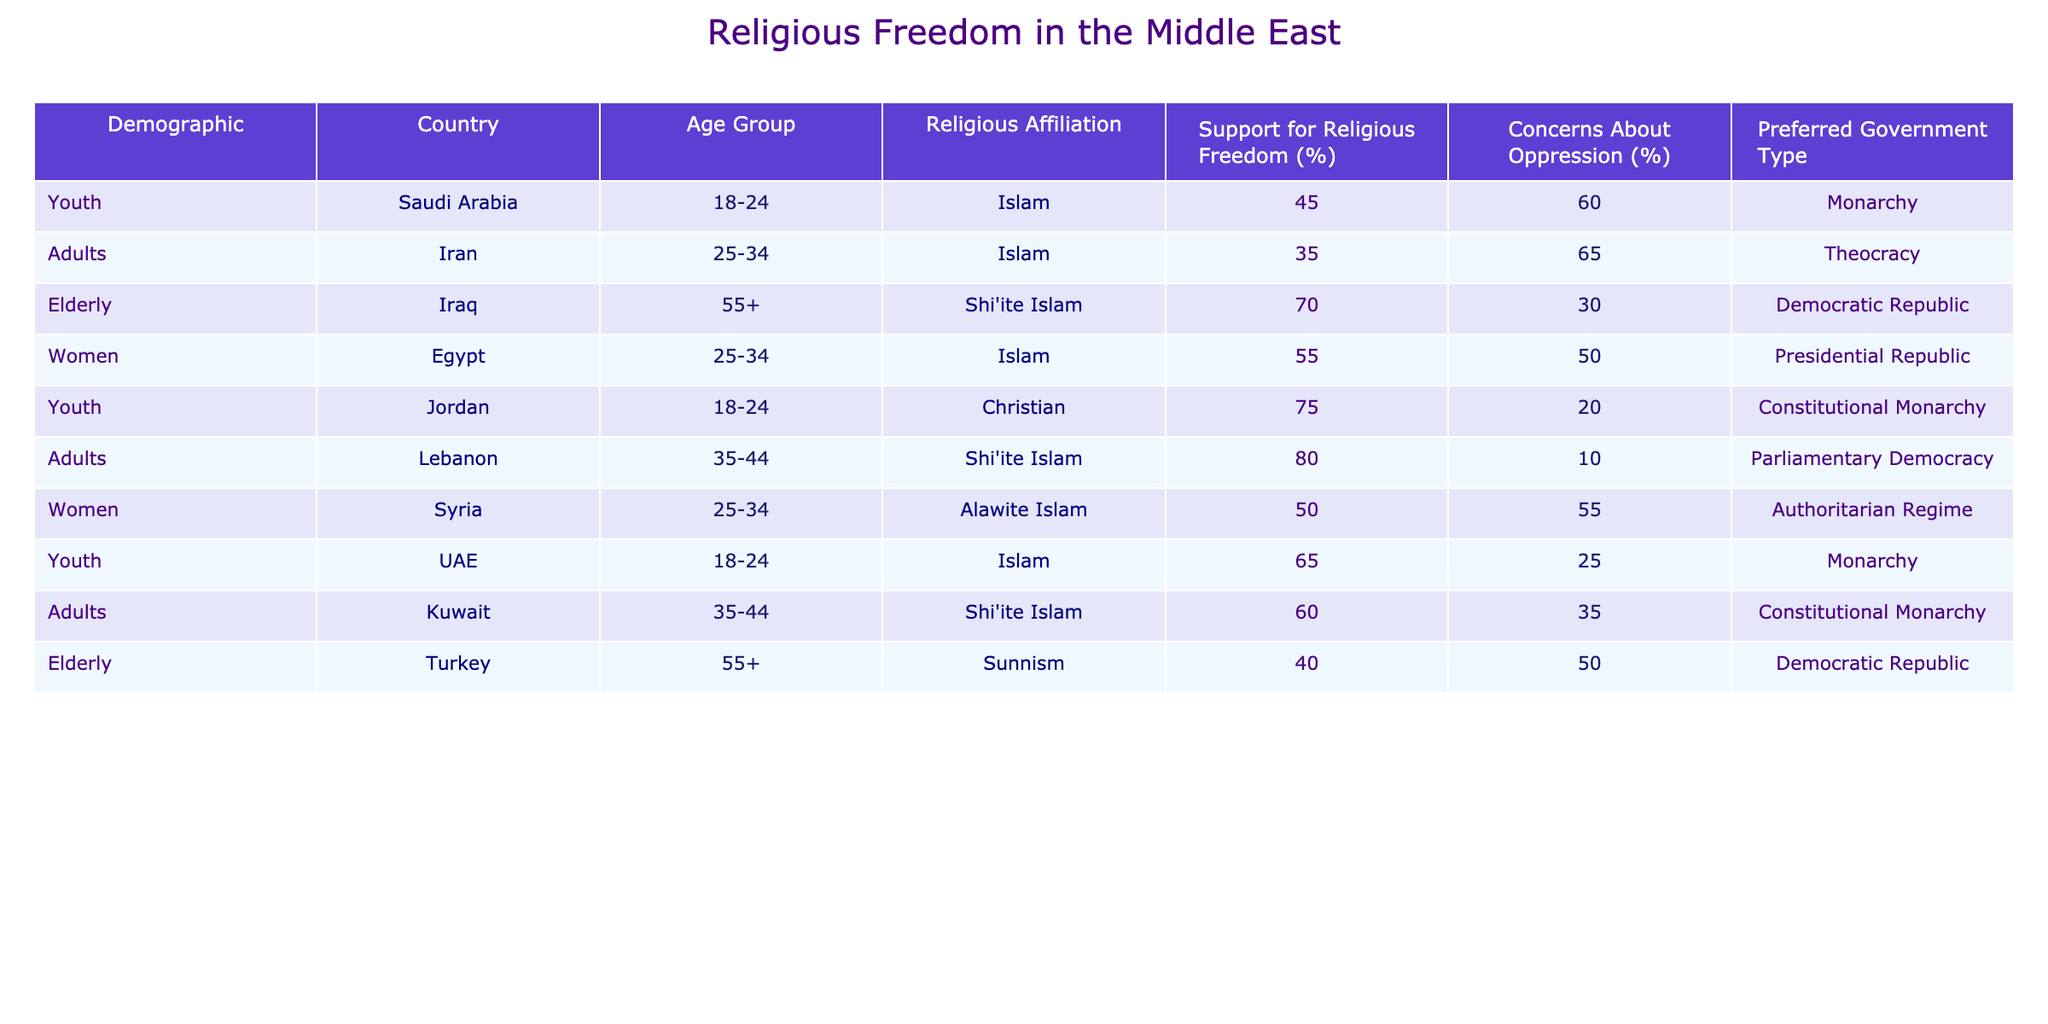What percentage of youth in Saudi Arabia support religious freedom? From the table, under the Saudi Arabia entry and the youth demographic (18-24 age group), the support for religious freedom is listed as 45%.
Answer: 45% Which country has the highest percentage of support for religious freedom among Shi'ite Muslims? Looking at the table, Lebanon has the highest support for religious freedom at 80%, under the adults demographic (35-44 age group).
Answer: Lebanon, 80% Is there a group in Iraq that has more concerns about oppression than support for religious freedom? In the table, the elderly demographic (55+) identified as Shi'ite Islam in Iraq shows support for religious freedom at 70% and concerns about oppression at 30%, which means support is higher than concerns. Therefore, the answer is no.
Answer: No What is the average support for religious freedom among women across the different countries listed? From the table, the support for religious freedom among women are: Egypt (55%), Syria (50%). Adding these gives 105%, and dividing by 2 leads to an average of 52.5%.
Answer: 52.5% Which age group in Jordan has the highest support for religious freedom? The table lists one demographic for Jordan (youth, 18-24) which shows a support level of 75%. Since this is the only data point provided for Jordan, it is confirmed that the youth group is the highest support.
Answer: Youth, 75% How do concerns about oppression compare between the youth in UAE and adults in Kuwait? The table shows that youth in UAE have concerns about oppression at 25% while adults in Kuwait have concerns at 35%. Therefore, adults in Kuwait have higher concerns about oppression by a difference of 10%.
Answer: Adults in Kuwait, 10% higher Is support for religious freedom generally higher among the elderly compared to youth across the table? The table shows the following averages: youth support (Saudi Arabia 45%, Jordan 75%, UAE 65% gives 61.67%) and elderly support (Iraq 70%, Turkey 40% gives 55%). The elderly group averages lower support than the youth group, concluding that youth have generally higher support.
Answer: No What percentage of Shi'ite Muslims in Lebanon are concerned about oppression? Referring to the table, Shi'ite Muslims in Lebanon (demographic adults, 35-44) have concerns about oppression listed at 10%.
Answer: 10% Which demographic shows the least concerns about oppression? Analyzing the table, the demographic with the least concerns about oppression is the adults in Lebanon, with only 10% expressing concerns, making it the lowest percentage shown.
Answer: Adults in Lebanon, 10% 